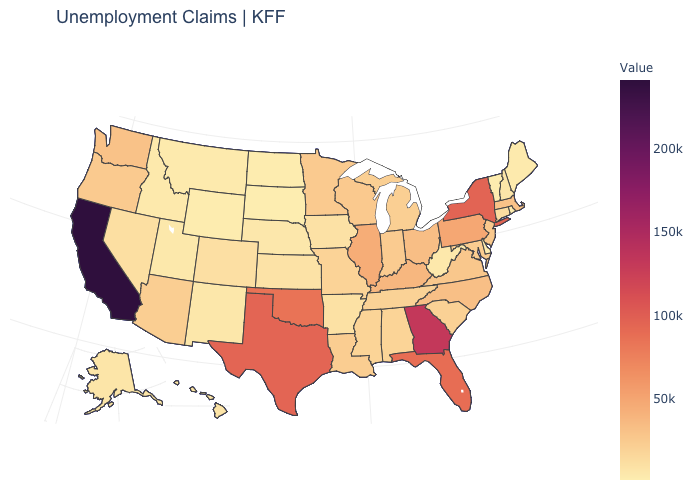Among the states that border Nebraska , does South Dakota have the lowest value?
Keep it brief. Yes. Among the states that border New Mexico , does Utah have the lowest value?
Keep it brief. Yes. Among the states that border Maryland , does West Virginia have the highest value?
Answer briefly. No. Does Wisconsin have the highest value in the USA?
Be succinct. No. Among the states that border Massachusetts , which have the highest value?
Answer briefly. New York. Does Vermont have the lowest value in the Northeast?
Concise answer only. Yes. Among the states that border New Mexico , which have the highest value?
Short answer required. Texas. Does Colorado have a higher value than Georgia?
Be succinct. No. Does New York have a higher value than Arkansas?
Be succinct. Yes. 